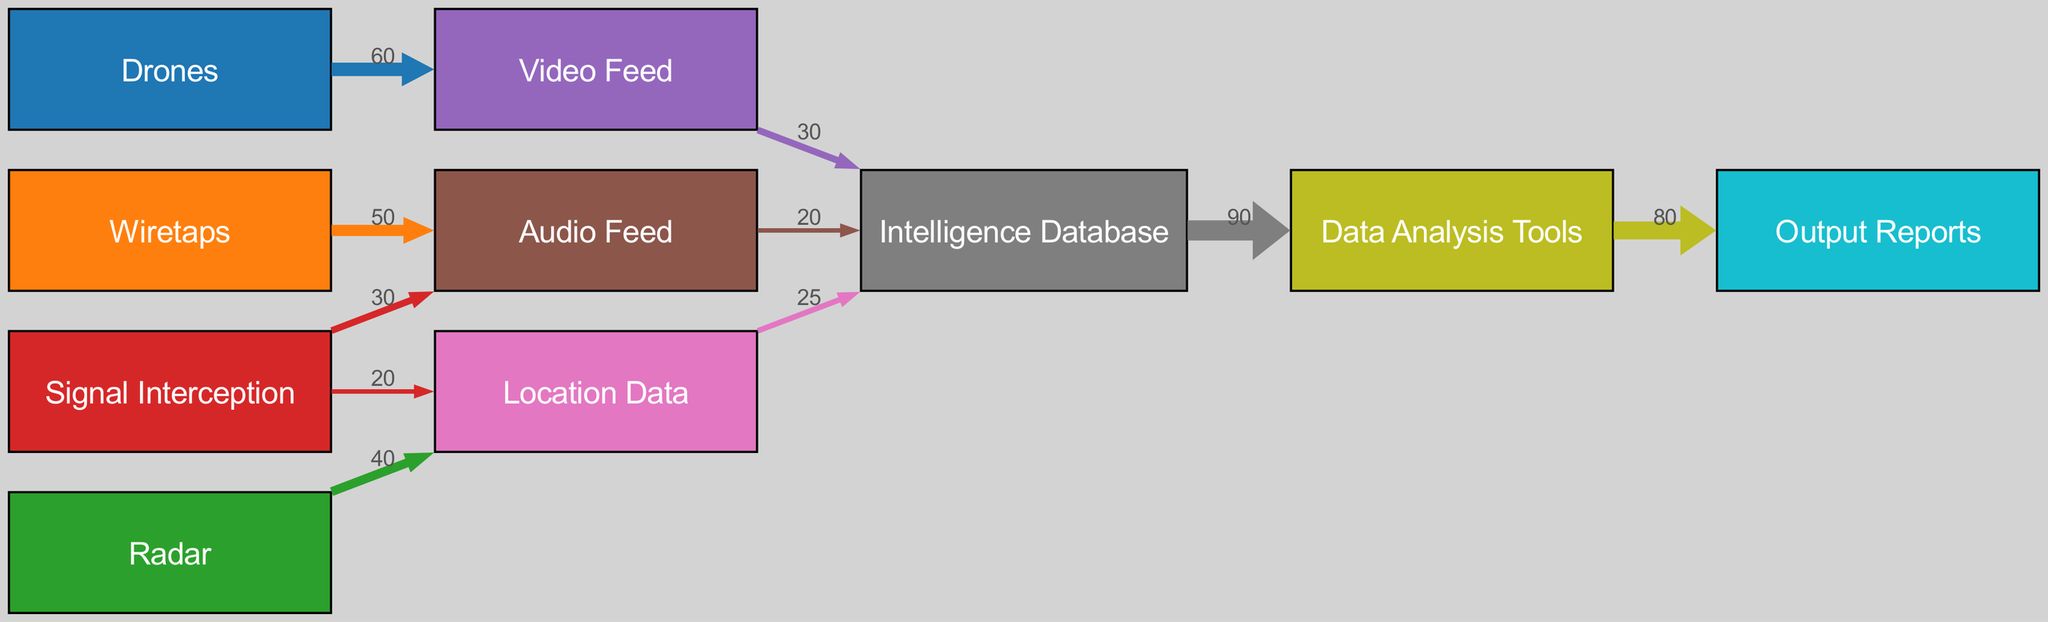What is the total number of nodes in the diagram? The diagram consists of 10 distinct nodes representing various surveillance technologies and data processing elements. These are: Drones, Wiretaps, Radar, Signal Interception, Video Feed, Audio Feed, Location Data, Intelligence Database, Data Analysis Tools, and Output Reports. Counting these gives us a total of 10 nodes.
Answer: 10 What is the value of the link from Drones to Video Feed? The diagram shows a flow of data from the Drones to the Video Feed, with a specified value of 60. This indicates the volume of data transmitted from Drones specifically to Video Feed.
Answer: 60 Which technology provides the most Audio Feed data? According to the diagram, both Wiretaps and Signal Interception contribute to Audio Feed, with Wiretaps providing 50 and Signal Interception providing 30. Therefore, Wiretaps provides the most Audio Feed data of 50.
Answer: Wiretaps What is the total volume of data flowing into the Intelligence Database? To find the total volume flowing into the Intelligence Database, we sum the incoming values of Video Feed (30), Audio Feed (20), and Location Data (25). The total is 30 + 20 + 25 = 75.
Answer: 75 Which technology contributes to both Audio Feed and Location Data? Looking at the diagram, Signal Interception sends data to both Audio Feed (30) and Location Data (20). This indicates that Signal Interception is the technology that contributes to both data categories.
Answer: Signal Interception What is the value of the link from Intelligence Database to Data Analysis Tools? The diagram specifies a link from the Intelligence Database to Data Analysis Tools with a value of 90. This represents the volume of data that transitions from the Intelligence Database to the tools used for analysis.
Answer: 90 How many edges connect to the Output Reports node? The diagram shows one direct edge leading to the Output Reports node, which receives data from Data Analysis Tools. Therefore, there is one edge connecting to the Output Reports node.
Answer: 1 What is the cumulative volume of data from Signal Interception to the Intelligence Database? Signal Interception contributes a total volume of 50 to the Intelligence Database, which includes 30 to Audio Feed and 20 to Location Data. Both of these ultimately connect to the Intelligence Database; thus, the cumulative volume from Signal Interception is 50.
Answer: 50 